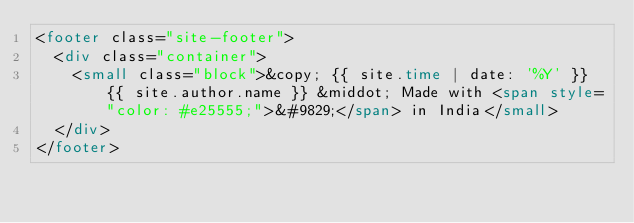Convert code to text. <code><loc_0><loc_0><loc_500><loc_500><_HTML_><footer class="site-footer">
  <div class="container">
    <small class="block">&copy; {{ site.time | date: '%Y' }} {{ site.author.name }} &middot; Made with <span style="color: #e25555;">&#9829;</span> in India</small>
  </div>
</footer>
</code> 